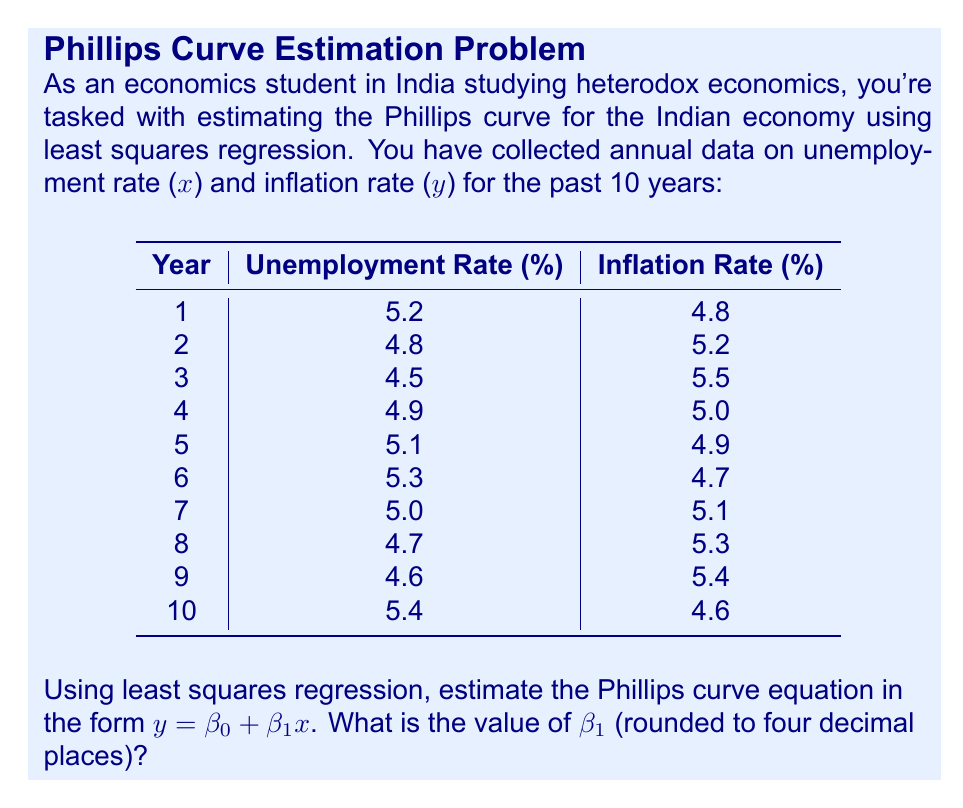Could you help me with this problem? To estimate the Phillips curve using least squares regression, we need to calculate $\beta_0$ and $\beta_1$ in the equation $y = \beta_0 + \beta_1x$. We'll focus on finding $\beta_1$.

The formula for $\beta_1$ is:

$$\beta_1 = \frac{n\sum xy - \sum x \sum y}{n\sum x^2 - (\sum x)^2}$$

Where $n$ is the number of data points.

Step 1: Calculate the sums needed for the formula:
$n = 10$
$\sum x = 49.5$
$\sum y = 50.5$
$\sum xy = 250.59$
$\sum x^2 = 246.35$

Step 2: Calculate $(\sum x)^2$:
$(\sum x)^2 = 49.5^2 = 2450.25$

Step 3: Substitute values into the formula:

$$\beta_1 = \frac{10(250.59) - 49.5(50.5)}{10(246.35) - 2450.25}$$

Step 4: Simplify:

$$\beta_1 = \frac{2505.9 - 2499.75}{2463.5 - 2450.25}$$

$$\beta_1 = \frac{6.15}{13.25}$$

Step 5: Calculate and round to four decimal places:

$$\beta_1 \approx -0.4642$$

The negative value indicates an inverse relationship between unemployment and inflation, which is consistent with the traditional Phillips curve theory.
Answer: $-0.4642$ 